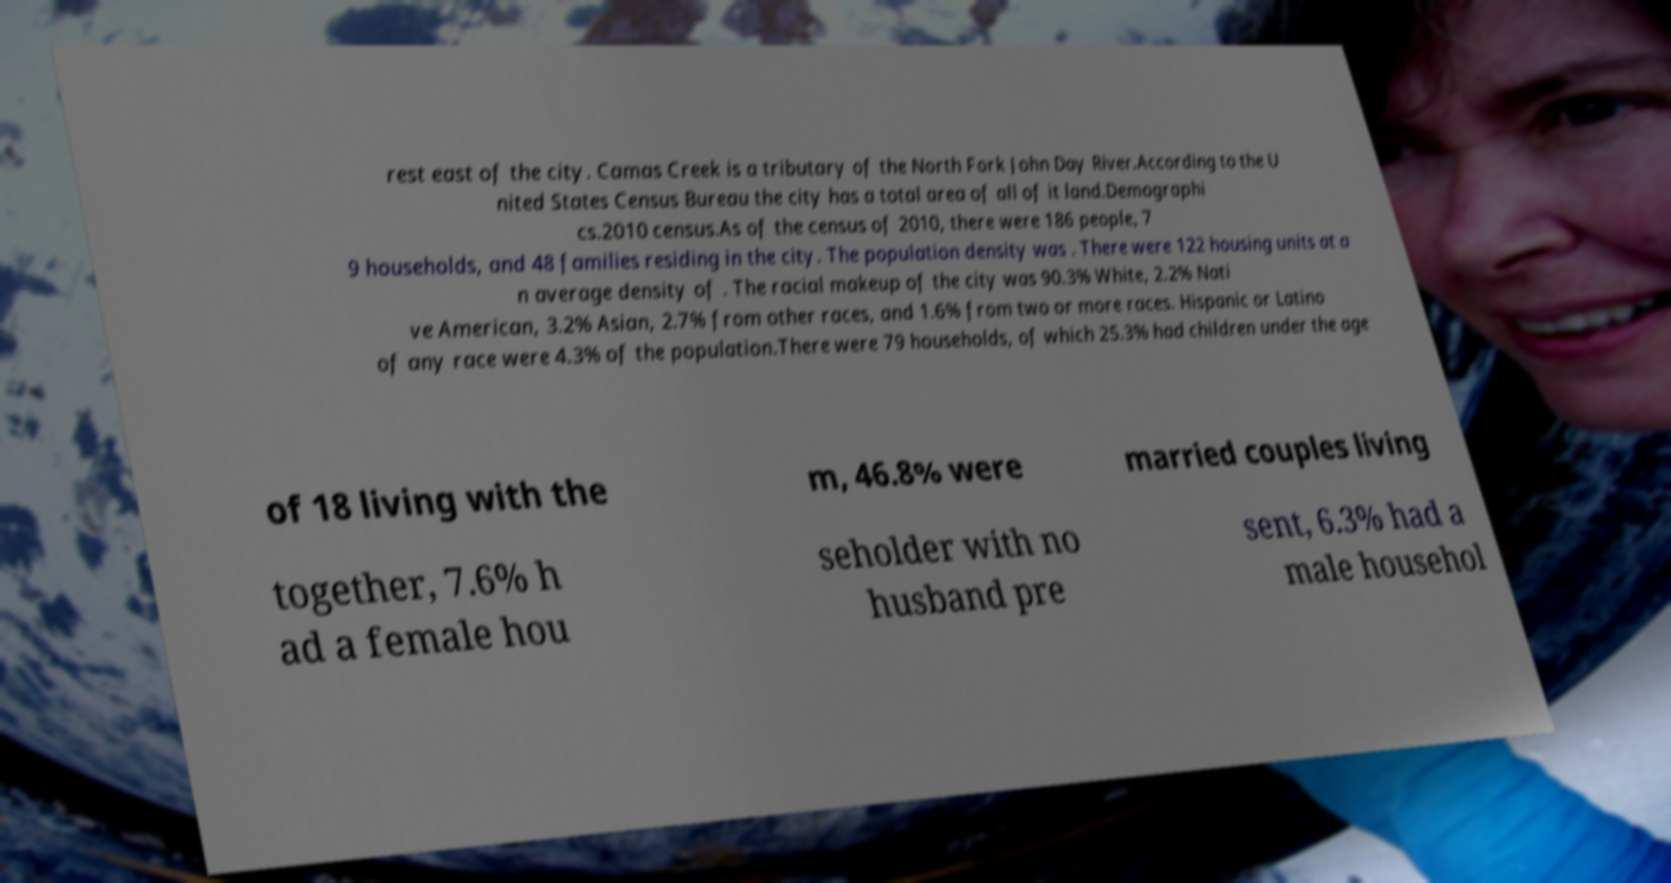What messages or text are displayed in this image? I need them in a readable, typed format. rest east of the city. Camas Creek is a tributary of the North Fork John Day River.According to the U nited States Census Bureau the city has a total area of all of it land.Demographi cs.2010 census.As of the census of 2010, there were 186 people, 7 9 households, and 48 families residing in the city. The population density was . There were 122 housing units at a n average density of . The racial makeup of the city was 90.3% White, 2.2% Nati ve American, 3.2% Asian, 2.7% from other races, and 1.6% from two or more races. Hispanic or Latino of any race were 4.3% of the population.There were 79 households, of which 25.3% had children under the age of 18 living with the m, 46.8% were married couples living together, 7.6% h ad a female hou seholder with no husband pre sent, 6.3% had a male househol 